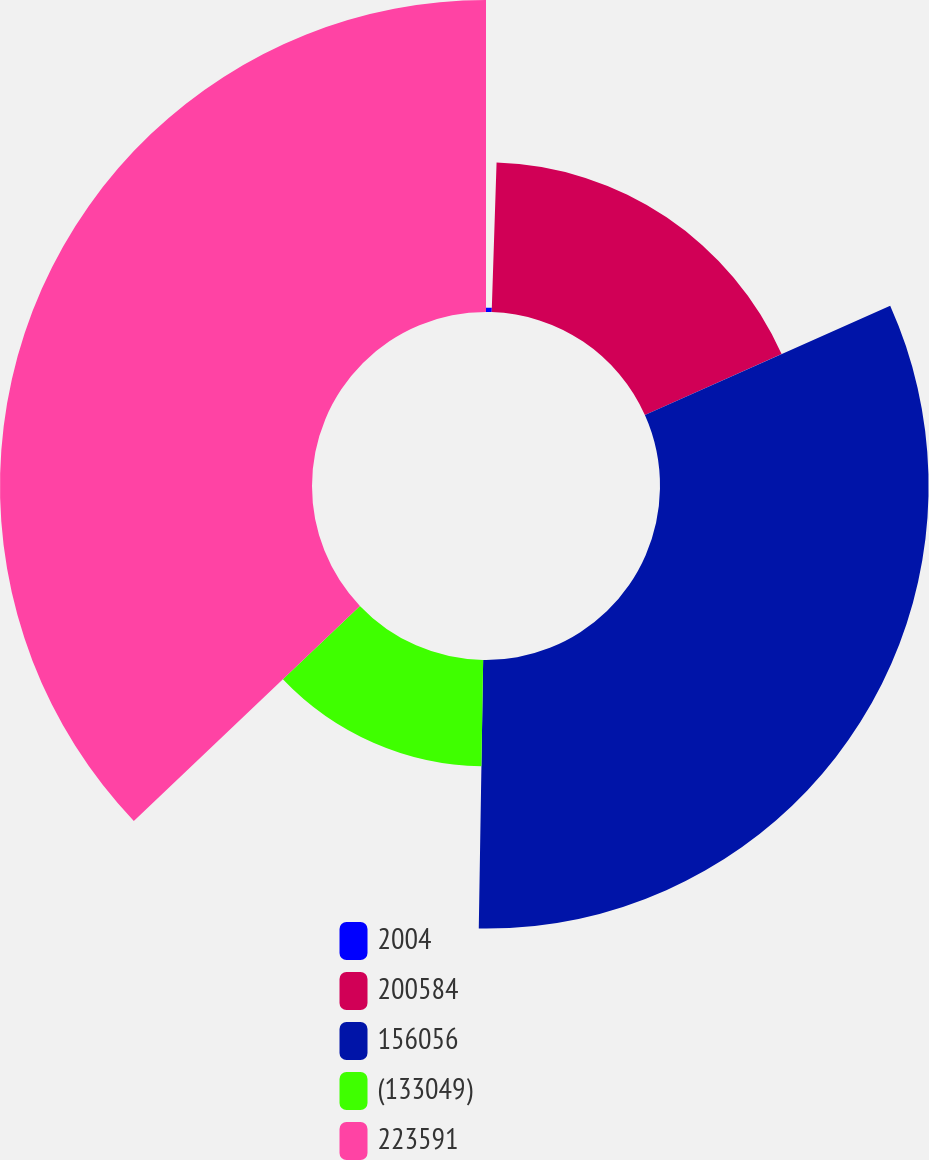<chart> <loc_0><loc_0><loc_500><loc_500><pie_chart><fcel>2004<fcel>200584<fcel>156056<fcel>(133049)<fcel>223591<nl><fcel>0.52%<fcel>17.8%<fcel>31.94%<fcel>12.64%<fcel>37.1%<nl></chart> 